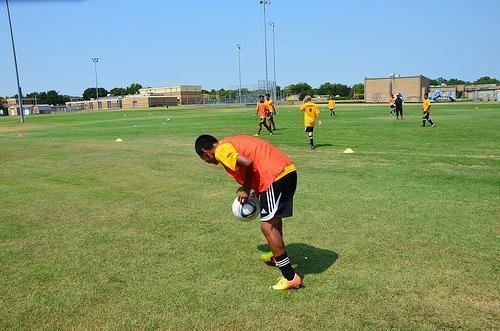How many people are holding a ball?
Give a very brief answer. 1. 